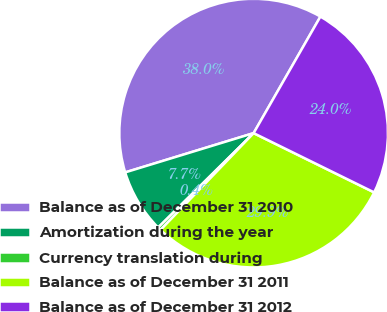Convert chart to OTSL. <chart><loc_0><loc_0><loc_500><loc_500><pie_chart><fcel>Balance as of December 31 2010<fcel>Amortization during the year<fcel>Currency translation during<fcel>Balance as of December 31 2011<fcel>Balance as of December 31 2012<nl><fcel>38.0%<fcel>7.69%<fcel>0.4%<fcel>29.91%<fcel>23.99%<nl></chart> 